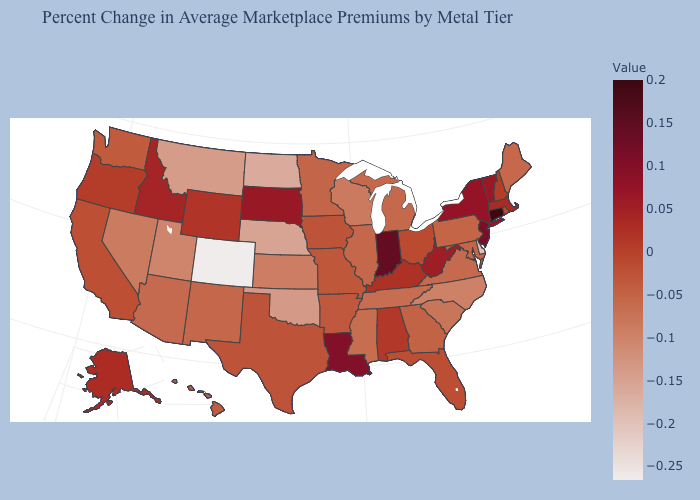Does Maine have the lowest value in the Northeast?
Answer briefly. Yes. Which states have the lowest value in the USA?
Short answer required. Colorado. 